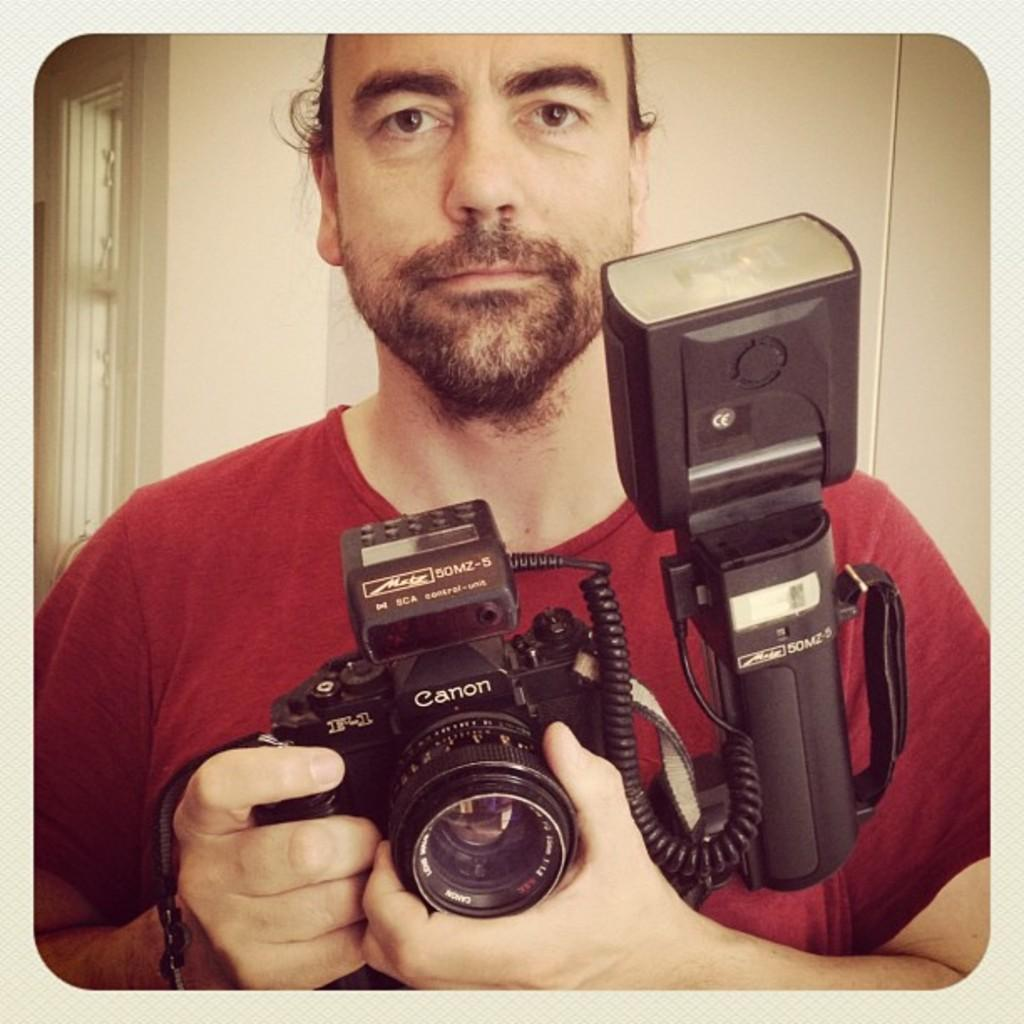What is the main subject in the foreground of the image? There is a person in the foreground of the image. What is the person holding in their hand? The person is holding a camera in their hand. What can be seen in the background of the image? There is a wall and a window in the background of the image. Can you describe the setting of the image? The image might have been taken in a room, as indicated by the presence of a wall and a window in the background. What type of surprise is the person about to reveal in the image? There is no indication of a surprise in the image; the person is simply holding a camera. How does the person plan to measure the distance between the wall and the window in the image? There is no indication of any measuring activity in the image; the person is holding a camera, and the wall and window are in the background. 